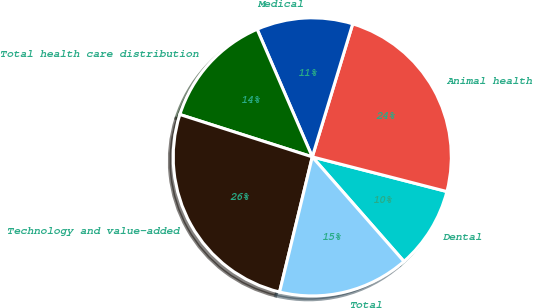Convert chart to OTSL. <chart><loc_0><loc_0><loc_500><loc_500><pie_chart><fcel>Dental<fcel>Animal health<fcel>Medical<fcel>Total health care distribution<fcel>Technology and value-added<fcel>Total<nl><fcel>9.53%<fcel>24.32%<fcel>11.19%<fcel>13.58%<fcel>26.15%<fcel>15.24%<nl></chart> 